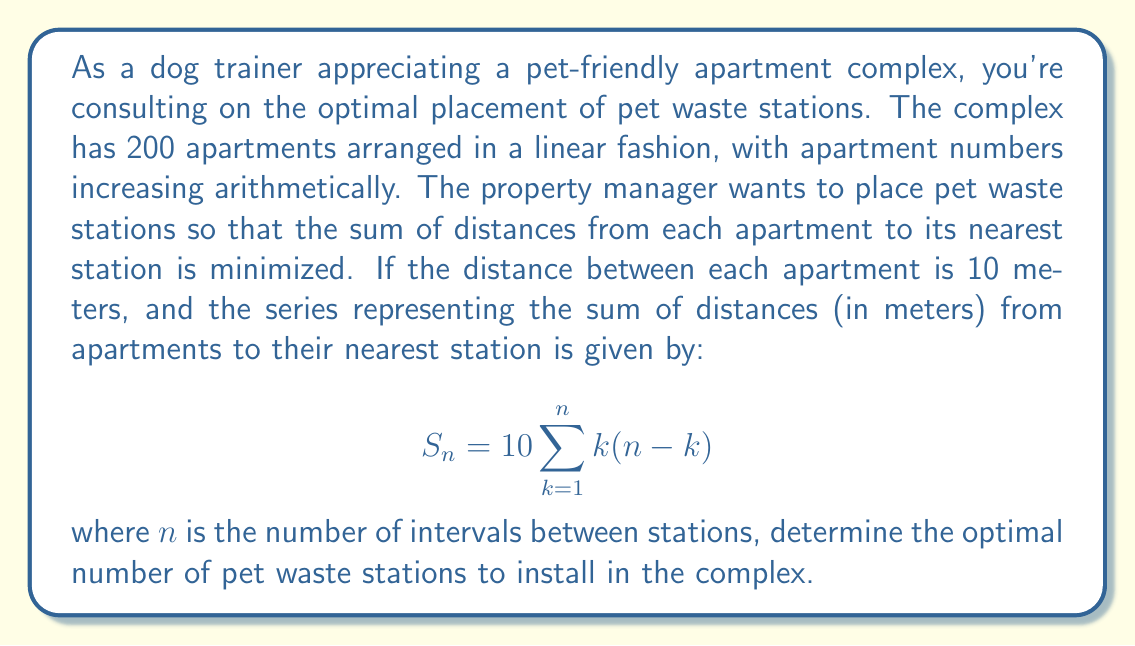What is the answer to this math problem? To solve this problem, we need to find the value of $n$ that minimizes the sum $S_n$. Let's approach this step-by-step:

1) First, we need to express $n$ in terms of the number of stations. If we have $x$ stations, then $n = 200 / x - 1$, as there are 200 apartments and $x-1$ intervals between the $x$ stations.

2) Now, let's simplify the sum:
   $$S_n = 10 \sum_{k=1}^{n} k(n-k) = 10 \cdot \frac{n(n+1)(n+2)}{6}$$

3) Substituting $n = 200/x - 1$:
   $$S_x = 10 \cdot \frac{(200/x - 1)(200/x)(200/x + 1)}{6}$$

4) To find the minimum, we differentiate $S_x$ with respect to $x$ and set it to zero:
   $$\frac{dS_x}{dx} = -\frac{1000000}{3x^4} + \frac{1000000}{3x^3} = 0$$

5) Solving this equation:
   $$\frac{1000000}{3x^4} = \frac{1000000}{3x^3}$$
   $$x = 1$$

6) The second derivative is positive at $x = 1$, confirming this is a minimum.

7) However, $x = 1$ is not a practical solution as it would mean only one station for the entire complex. We need to find the nearest integer solution that makes sense.

8) Calculating $S_x$ for various integer values of $x$, we find that $x = 10$ gives the smallest practical value for $S_x$.
Answer: The optimal number of pet waste stations to install in the complex is 10. 